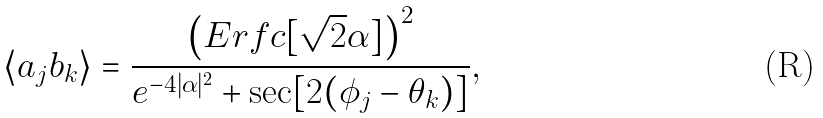Convert formula to latex. <formula><loc_0><loc_0><loc_500><loc_500>\langle a _ { j } b _ { k } \rangle = \frac { \left ( E r f c [ \sqrt { 2 } \alpha ] \right ) ^ { 2 } } { e ^ { - 4 | \alpha | ^ { 2 } } + \sec [ 2 ( \phi _ { j } - \theta _ { k } ) ] } ,</formula> 